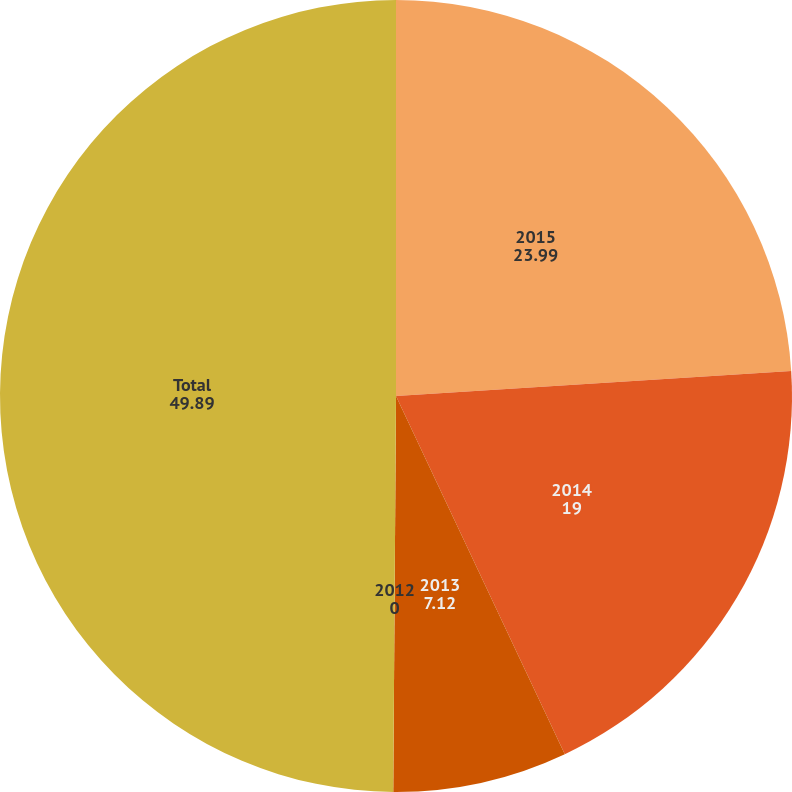<chart> <loc_0><loc_0><loc_500><loc_500><pie_chart><fcel>2015<fcel>2014<fcel>2013<fcel>2012<fcel>Total<nl><fcel>23.99%<fcel>19.0%<fcel>7.12%<fcel>0.0%<fcel>49.89%<nl></chart> 